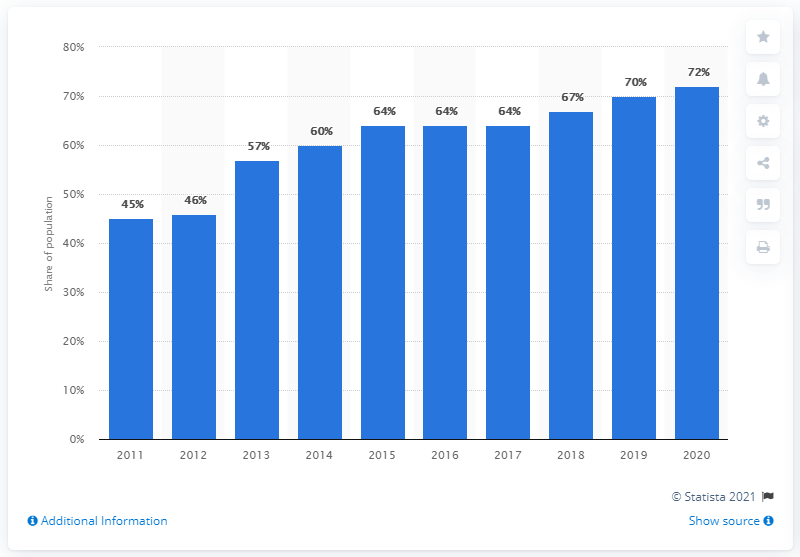Indicate a few pertinent items in this graphic. In 2020, over two thirds of the Belgian population utilized e-commerce. 